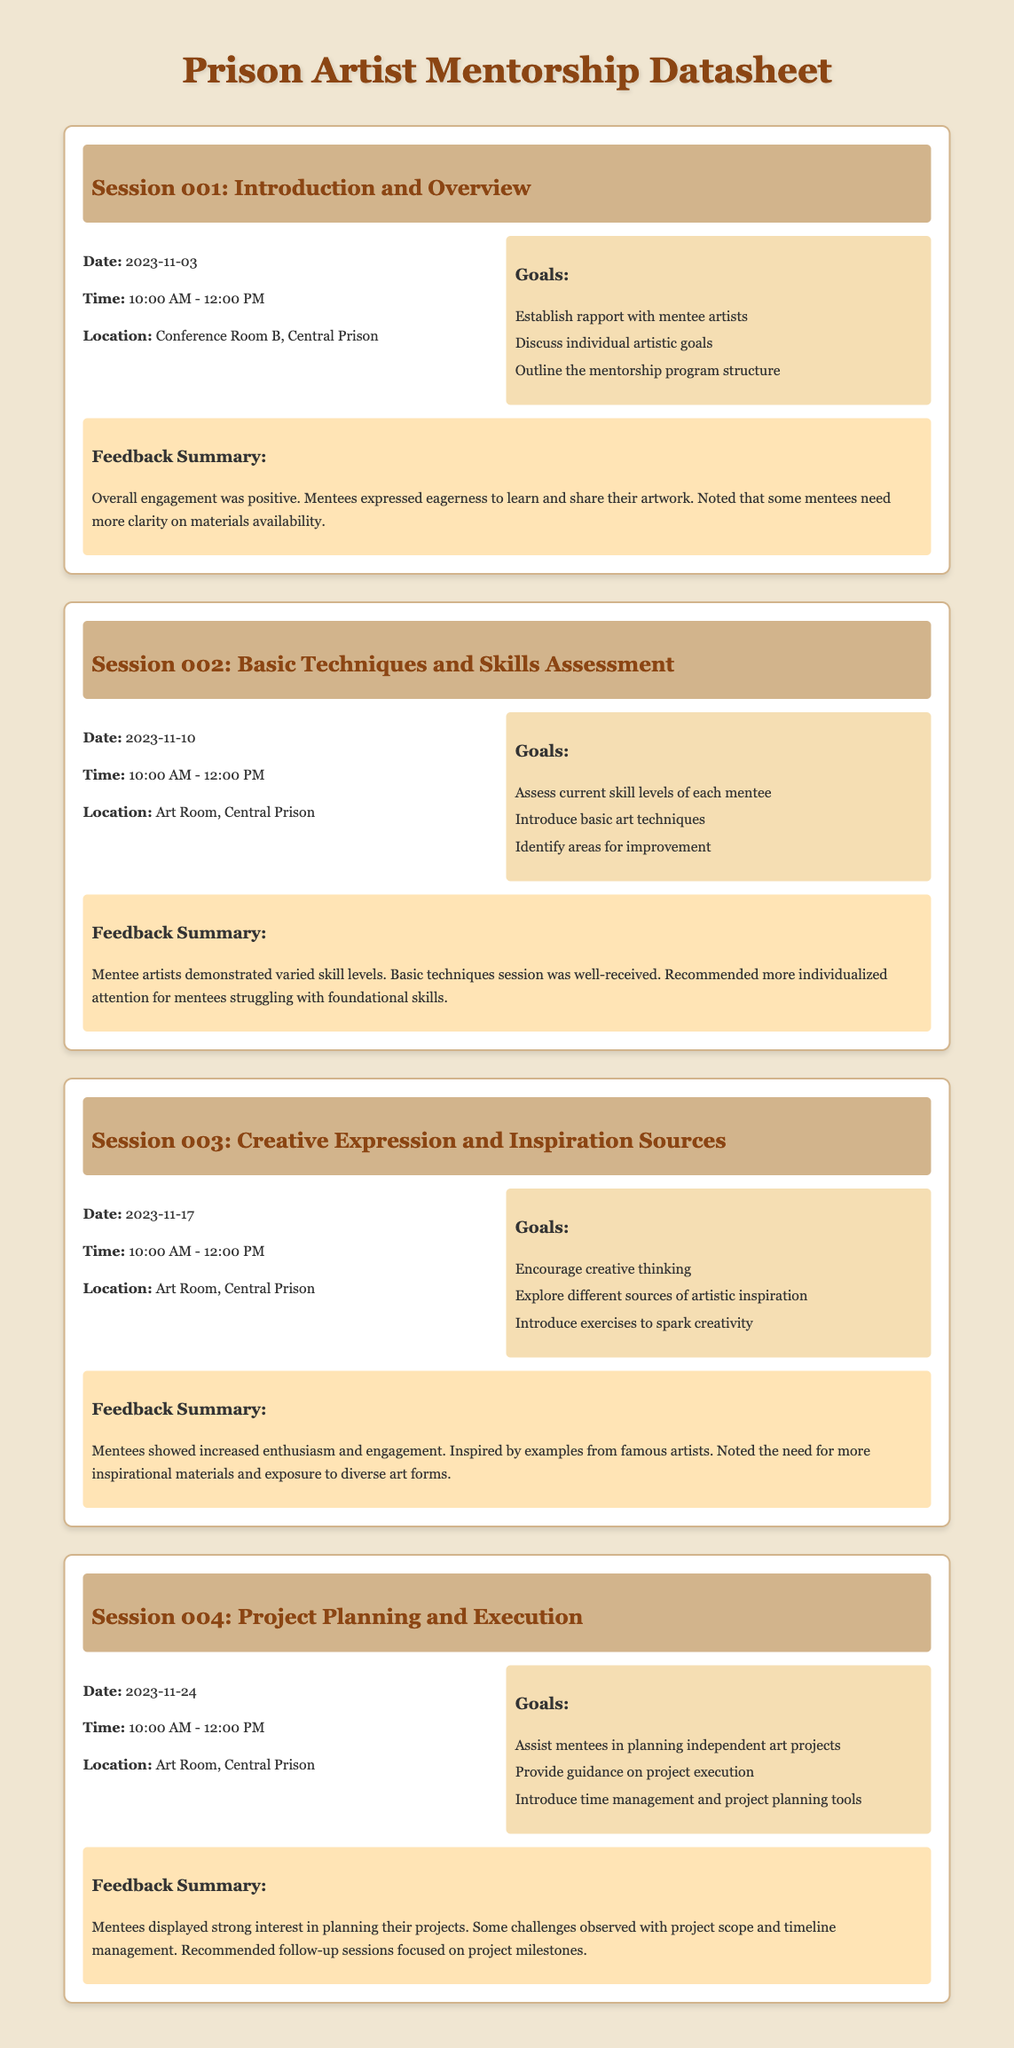What is the date of Session 001? The date of Session 001 is explicitly mentioned in the document.
Answer: 2023-11-03 What is the time for Session 002? The document states the time for each session clearly.
Answer: 10:00 AM - 12:00 PM Where is Session 003 held? The location for each session is provided in the details section.
Answer: Art Room, Central Prison What is one of the goals for Session 004? The goals for each session are listed which highlights key focus areas.
Answer: Assist mentees in planning independent art projects What was noted about the feedback for all sessions? The feedback summary section provides insight into overall sentiments and observations.
Answer: Mentees expressed eagerness to learn Which session is focused on basic techniques? Each session has a specific focus area that is clearly indicated in the titles.
Answer: Session 002 How many sessions are outlined in the document? The document lists each session separately, providing clarity on the full schedule.
Answer: Four sessions What was a feedback point in Session 002? Feedback summaries include specific observations for improvement and engagement.
Answer: More individualized attention for mentees struggling with foundational skills What is a goal for Session 003? Each session lists goals to provide clear direction for the activities planned.
Answer: Encourage creative thinking 